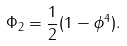Convert formula to latex. <formula><loc_0><loc_0><loc_500><loc_500>\Phi _ { 2 } = \frac { 1 } { 2 } ( 1 - \phi ^ { 4 } ) .</formula> 